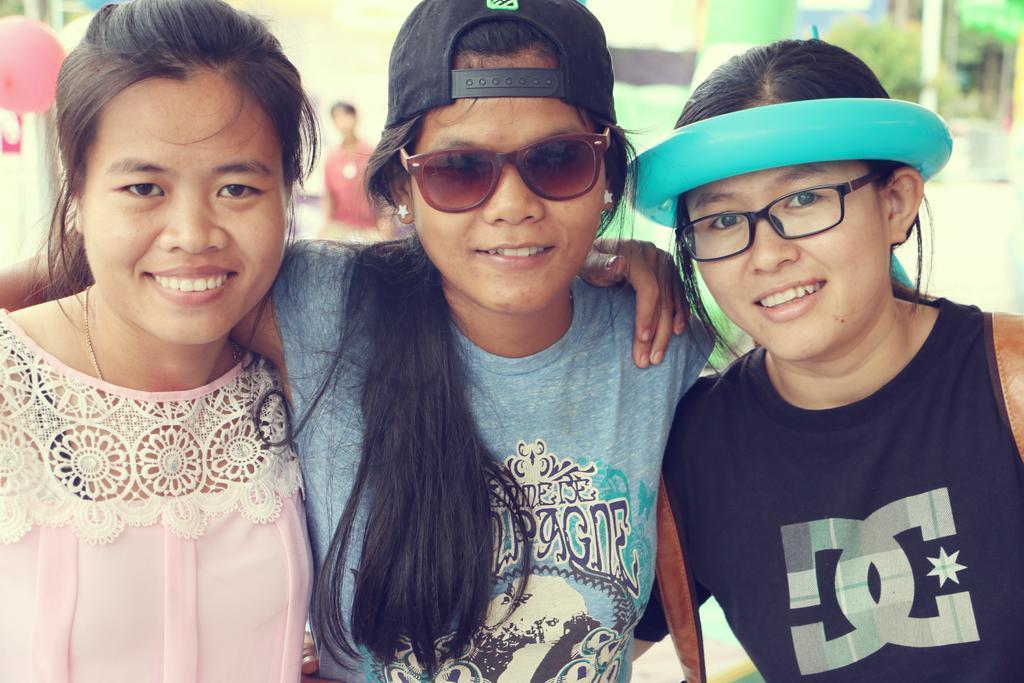How would you summarize this image in a sentence or two? In this image there are three women standing. They are smiling. The woman in the center is wearing a cap. Behind them there is a person standing. In the top left there is a balloon to the metal rod. The background is blurry. 